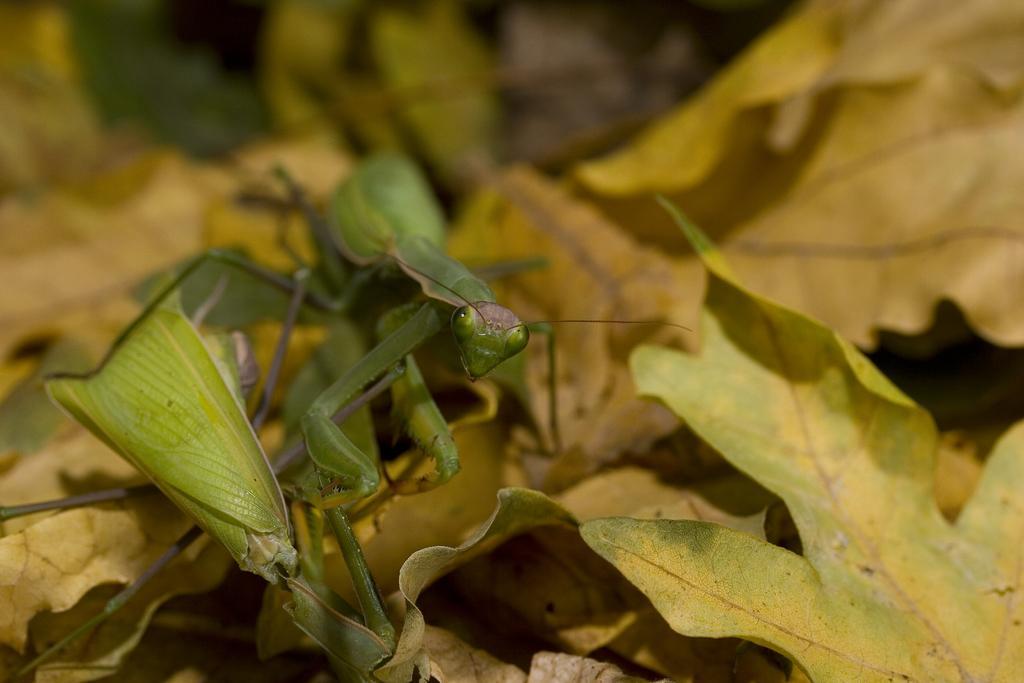In one or two sentences, can you explain what this image depicts? In the center of the image we can see grasshopper on the leaves. 